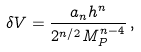<formula> <loc_0><loc_0><loc_500><loc_500>\delta V = \frac { a _ { n } h ^ { n } } { 2 ^ { n / 2 } M _ { P } ^ { n - 4 } } \, ,</formula> 